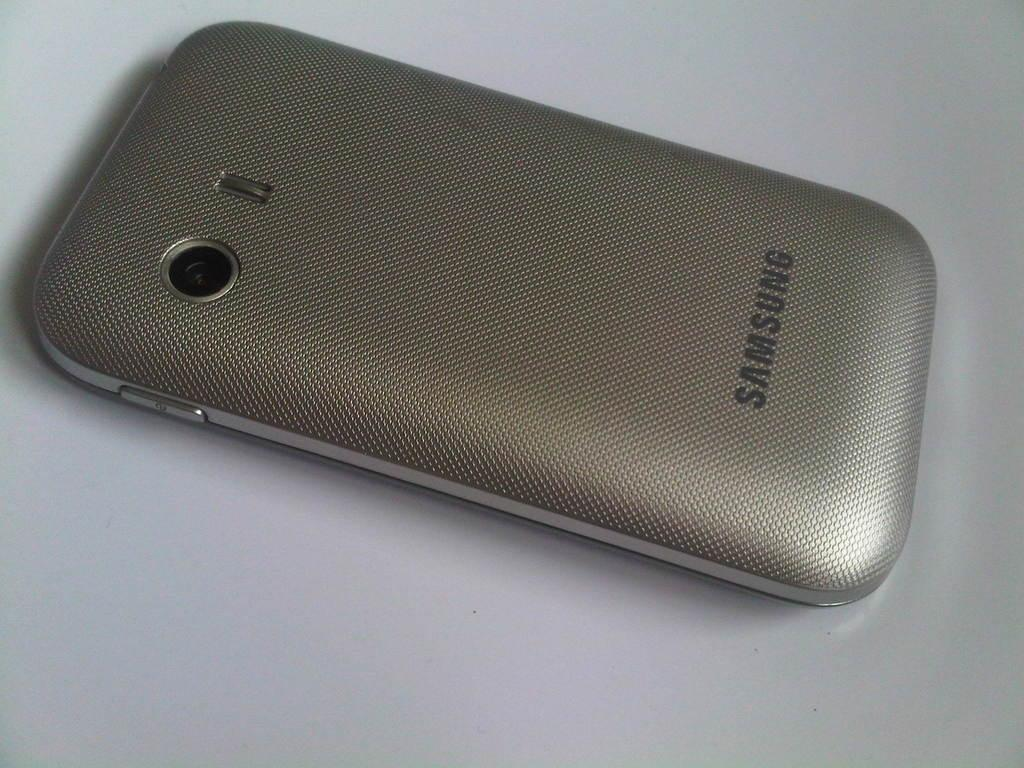<image>
Describe the image concisely. A Samsung phone is facedown on a grey surface. 